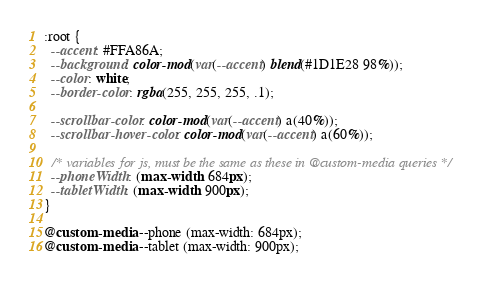Convert code to text. <code><loc_0><loc_0><loc_500><loc_500><_CSS_>:root {
  --accent: #FFA86A;
  --background: color-mod(var(--accent) blend(#1D1E28 98%));
  --color: white;
  --border-color: rgba(255, 255, 255, .1);

  --scrollbar-color: color-mod(var(--accent) a(40%));
  --scrollbar-hover-color: color-mod(var(--accent) a(60%));

  /* variables for js, must be the same as these in @custom-media queries */
  --phoneWidth: (max-width: 684px);
  --tabletWidth: (max-width: 900px);
}

@custom-media --phone (max-width: 684px);
@custom-media --tablet (max-width: 900px);
</code> 